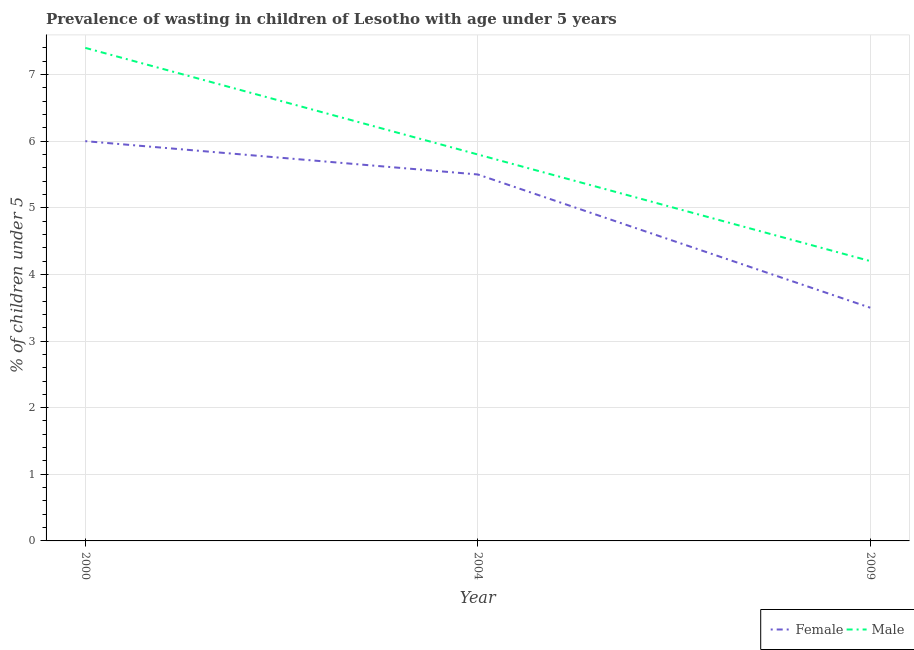What is the percentage of undernourished male children in 2000?
Provide a short and direct response. 7.4. In which year was the percentage of undernourished female children maximum?
Provide a succinct answer. 2000. In which year was the percentage of undernourished male children minimum?
Your response must be concise. 2009. What is the total percentage of undernourished male children in the graph?
Ensure brevity in your answer.  17.4. What is the difference between the percentage of undernourished male children in 2000 and that in 2009?
Provide a succinct answer. 3.2. What is the difference between the percentage of undernourished male children in 2009 and the percentage of undernourished female children in 2000?
Offer a terse response. -1.8. What is the average percentage of undernourished female children per year?
Ensure brevity in your answer.  5. In the year 2009, what is the difference between the percentage of undernourished male children and percentage of undernourished female children?
Provide a short and direct response. 0.7. What is the ratio of the percentage of undernourished female children in 2000 to that in 2009?
Provide a succinct answer. 1.71. Is the percentage of undernourished female children in 2000 less than that in 2004?
Offer a terse response. No. Is the difference between the percentage of undernourished female children in 2000 and 2009 greater than the difference between the percentage of undernourished male children in 2000 and 2009?
Keep it short and to the point. No. What is the difference between the highest and the second highest percentage of undernourished female children?
Your answer should be compact. 0.5. What is the difference between the highest and the lowest percentage of undernourished female children?
Your answer should be compact. 2.5. Does the percentage of undernourished female children monotonically increase over the years?
Give a very brief answer. No. What is the difference between two consecutive major ticks on the Y-axis?
Give a very brief answer. 1. Does the graph contain grids?
Your answer should be compact. Yes. How many legend labels are there?
Your answer should be very brief. 2. What is the title of the graph?
Offer a very short reply. Prevalence of wasting in children of Lesotho with age under 5 years. What is the label or title of the Y-axis?
Your response must be concise.  % of children under 5. What is the  % of children under 5 of Male in 2000?
Keep it short and to the point. 7.4. What is the  % of children under 5 of Male in 2004?
Your answer should be compact. 5.8. What is the  % of children under 5 in Female in 2009?
Your response must be concise. 3.5. What is the  % of children under 5 of Male in 2009?
Your response must be concise. 4.2. Across all years, what is the maximum  % of children under 5 in Male?
Offer a terse response. 7.4. Across all years, what is the minimum  % of children under 5 of Male?
Provide a short and direct response. 4.2. What is the total  % of children under 5 in Female in the graph?
Your answer should be very brief. 15. What is the difference between the  % of children under 5 in Male in 2000 and that in 2009?
Provide a succinct answer. 3.2. What is the difference between the  % of children under 5 of Male in 2004 and that in 2009?
Provide a succinct answer. 1.6. What is the difference between the  % of children under 5 in Female in 2004 and the  % of children under 5 in Male in 2009?
Provide a succinct answer. 1.3. What is the average  % of children under 5 in Male per year?
Offer a terse response. 5.8. In the year 2000, what is the difference between the  % of children under 5 in Female and  % of children under 5 in Male?
Your answer should be compact. -1.4. What is the ratio of the  % of children under 5 of Female in 2000 to that in 2004?
Offer a very short reply. 1.09. What is the ratio of the  % of children under 5 of Male in 2000 to that in 2004?
Provide a succinct answer. 1.28. What is the ratio of the  % of children under 5 in Female in 2000 to that in 2009?
Offer a very short reply. 1.71. What is the ratio of the  % of children under 5 of Male in 2000 to that in 2009?
Your answer should be compact. 1.76. What is the ratio of the  % of children under 5 in Female in 2004 to that in 2009?
Your answer should be compact. 1.57. What is the ratio of the  % of children under 5 of Male in 2004 to that in 2009?
Provide a short and direct response. 1.38. What is the difference between the highest and the second highest  % of children under 5 in Female?
Offer a very short reply. 0.5. What is the difference between the highest and the second highest  % of children under 5 in Male?
Keep it short and to the point. 1.6. 